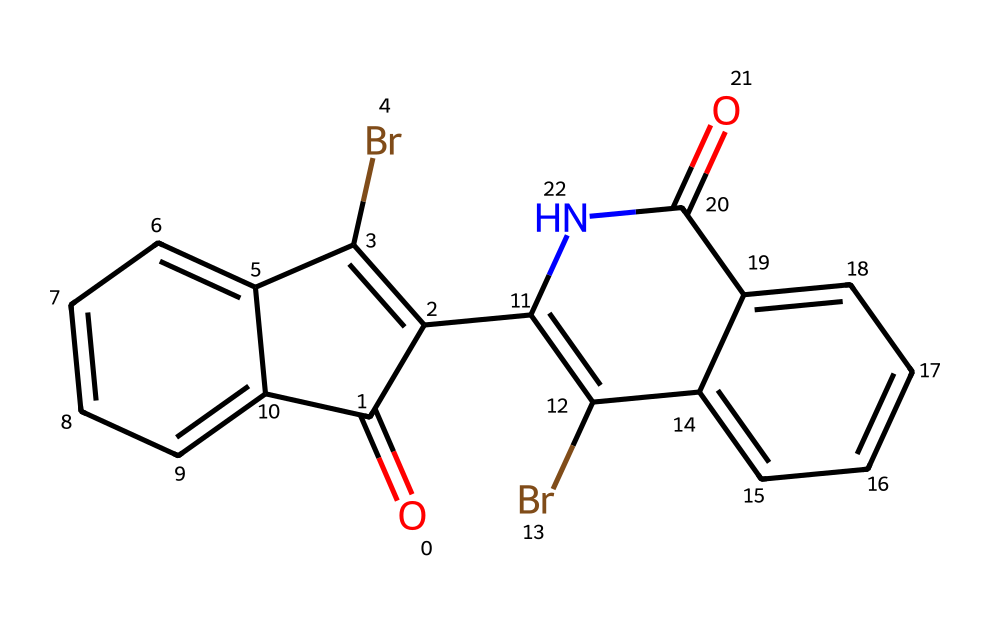What is the main element contributing to the color of Tyrian purple? The distinctive purple color of Tyrian purple is primarily attributed to the presence of bromine atoms in the chemical structure. The bromine atoms are integral to the chromophore that imparts the dye's color.
Answer: bromine How many rings are present in the structure of Tyrian purple? By examining the SMILES representation, we can identify four distinct cyclic structures (or rings) in the molecular composition, which are key characteristics of its structure.
Answer: four What type of dye is Tyrian purple classified as? Tyrian purple is classified as a natural dye, derived from marine mollusks, and is often recognized for its historical significance. Its structure indicates it is an organic dye as well.
Answer: natural dye How many carbon atoms are in the Tyrian purple molecule? Counting the carbon atoms in the chemical structure reveals a total of 14 carbon atoms, which can be determined by analyzing the molecular formula inferred from the SMILES notation.
Answer: fourteen What functional group is present in Tyrian purple's structure? The structure contains a ketone group, as indicated by the carbonyl (C=O) functional groups present in the molecule, which contributes to its chemical properties.
Answer: ketone What is the role of the amine group in Tyrian purple? The amine group (part of the molecular structure) can enhance the compound's solubility and binding ability to substrates, crucial for its function as a dye.
Answer: solubility What historical significance does Tyrian purple have? Tyrian purple was highly valued in ancient times, often associated with royalty and luxury, due to its unique pigment and labor-intensive production process from mollusks.
Answer: luxury 